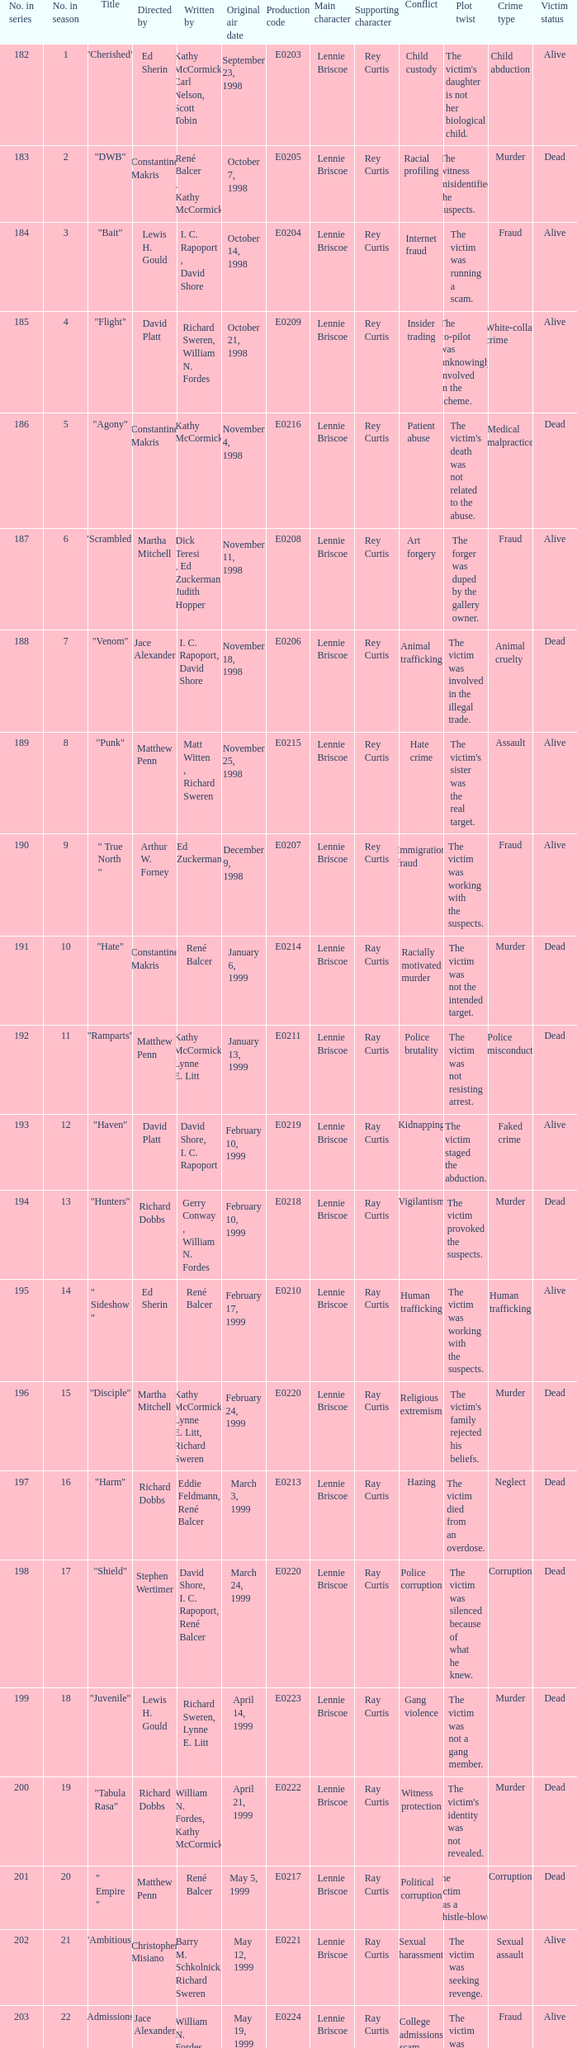The episode with original air date January 13, 1999 is written by who? Kathy McCormick, Lynne E. Litt. 